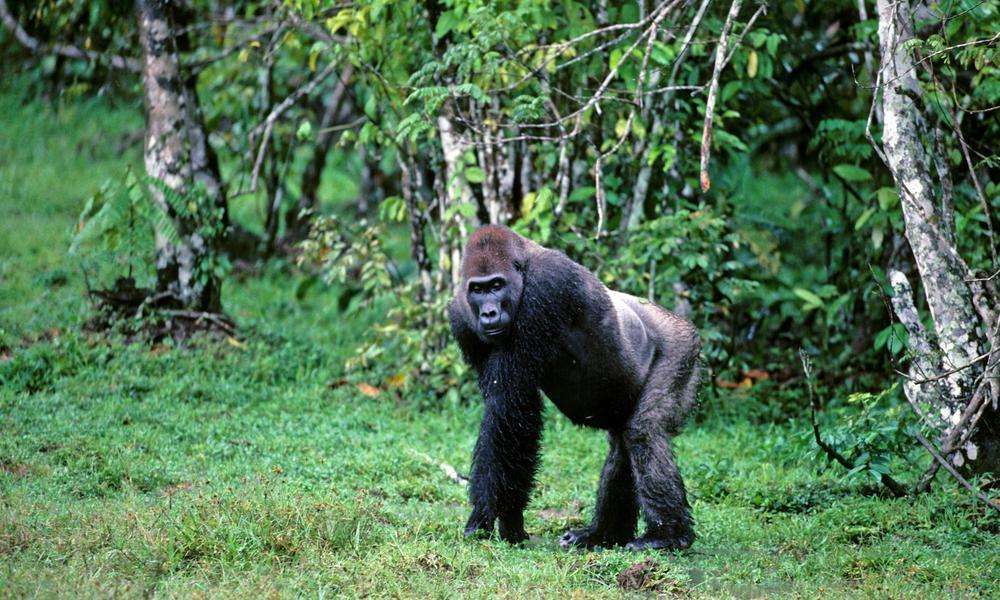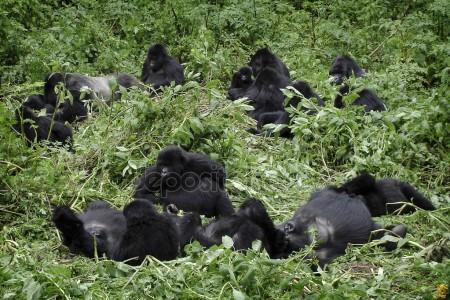The first image is the image on the left, the second image is the image on the right. For the images shown, is this caption "There is one gorilla walking and one that is stationary while facing to the left." true? Answer yes or no. No. The first image is the image on the left, the second image is the image on the right. For the images displayed, is the sentence "There are no more than two gorillas." factually correct? Answer yes or no. No. 